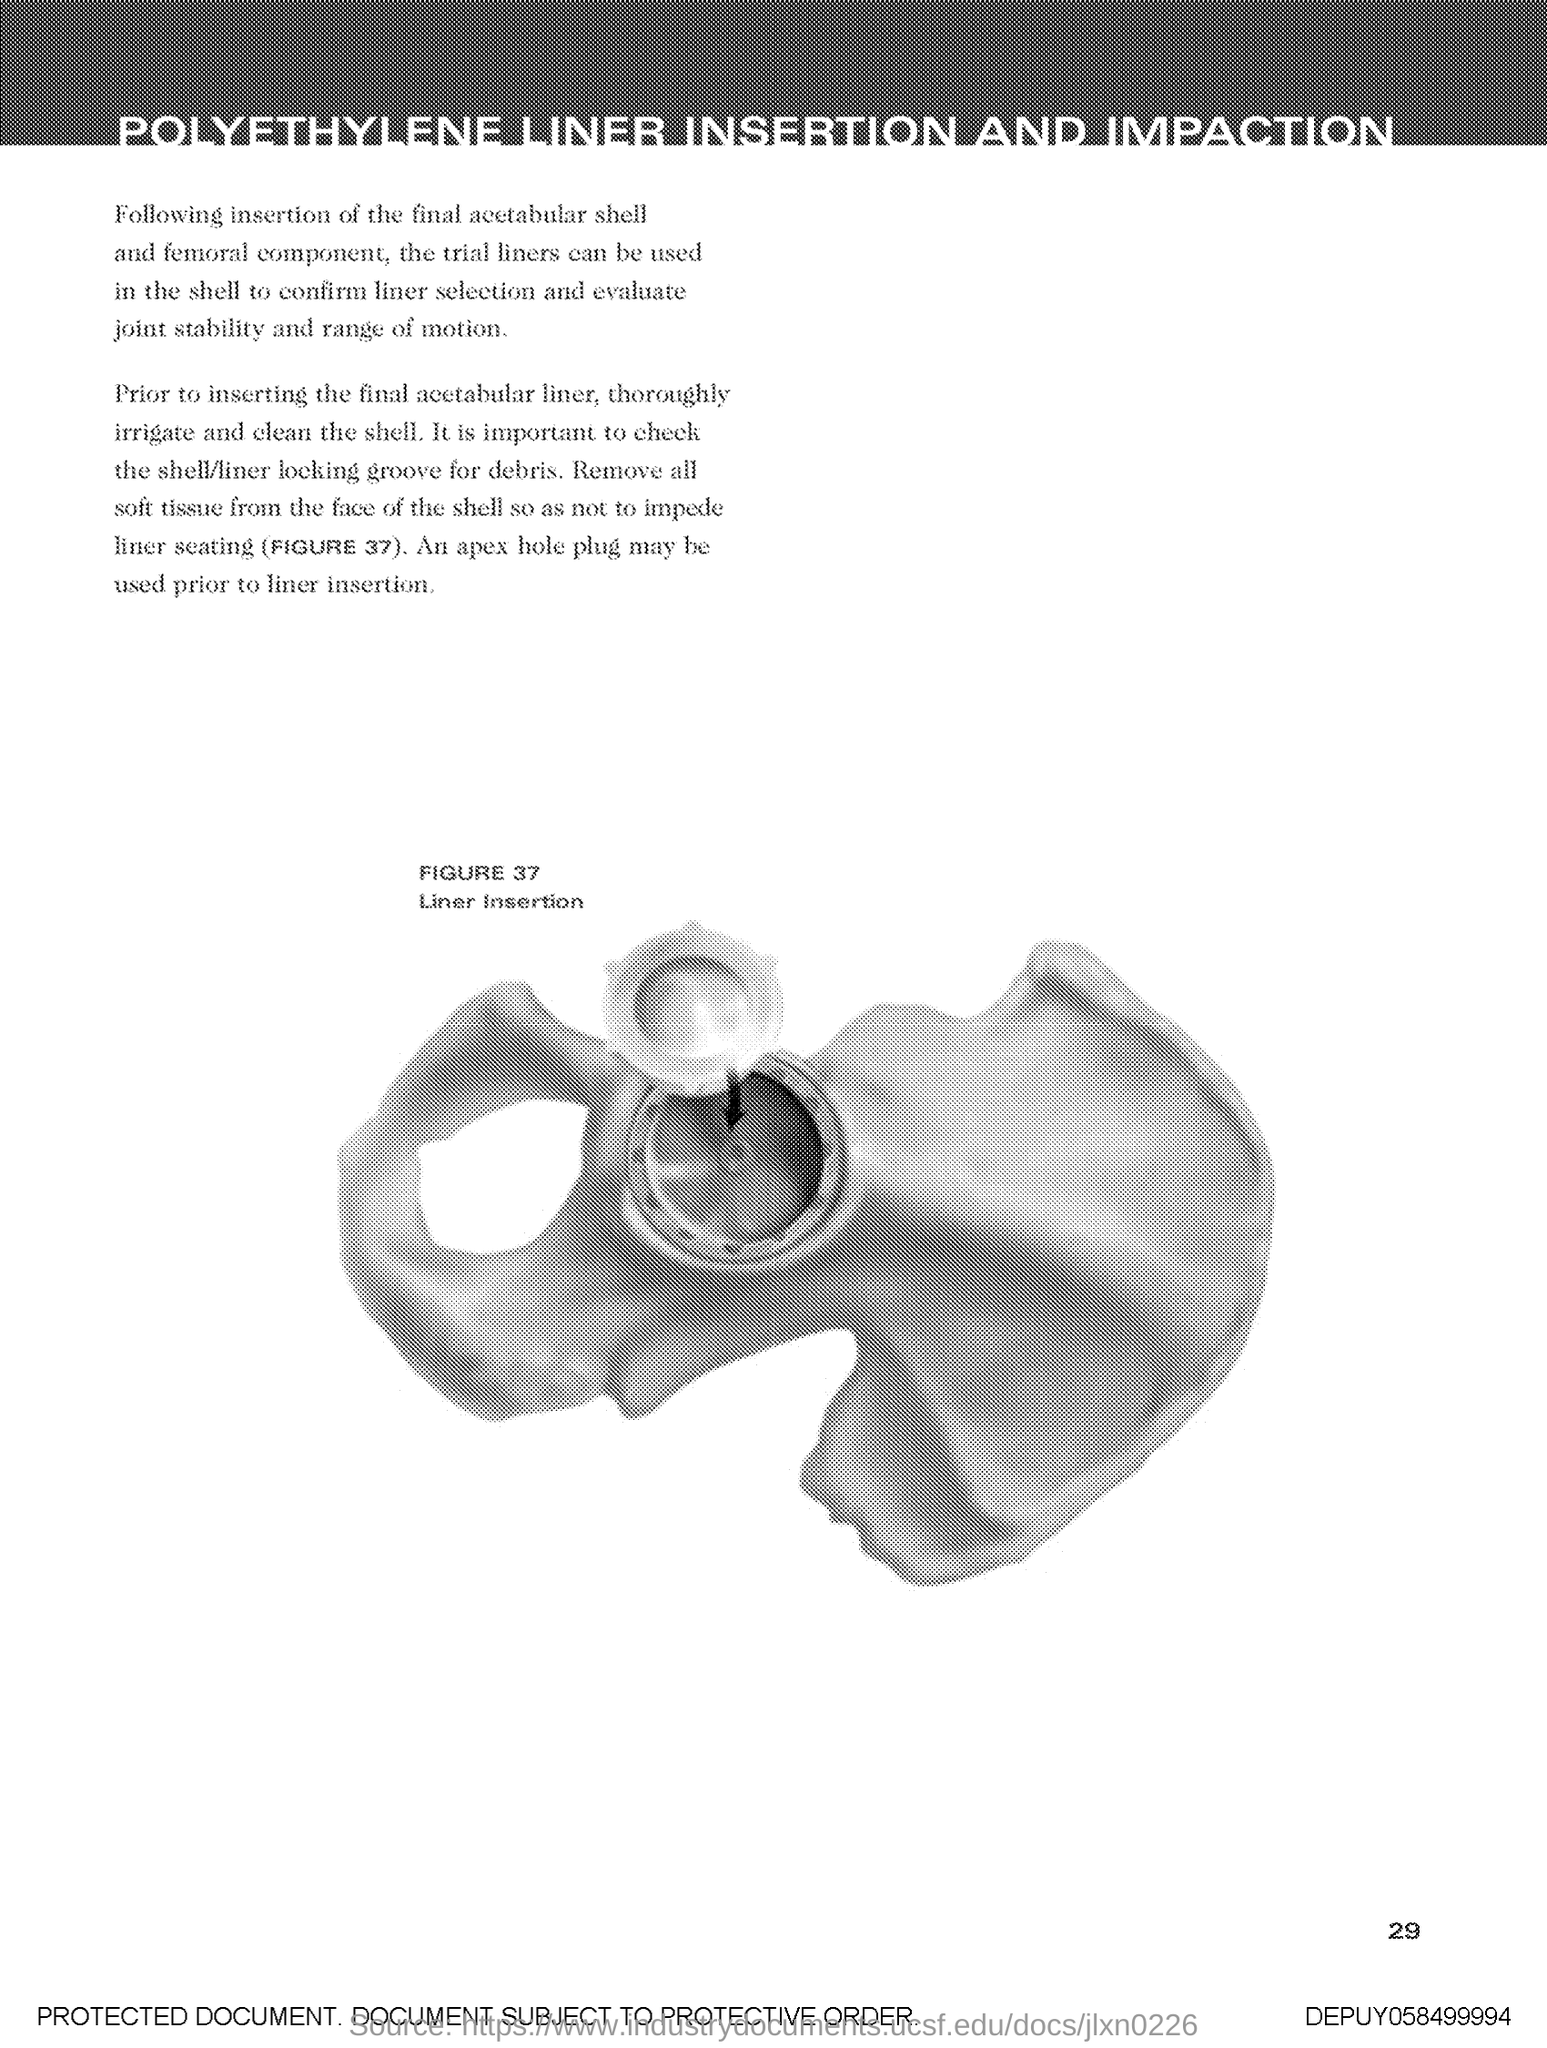Point out several critical features in this image. The figure name is Liner Insertion. The figure number is 37. 